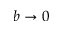Convert formula to latex. <formula><loc_0><loc_0><loc_500><loc_500>b \rightarrow 0</formula> 